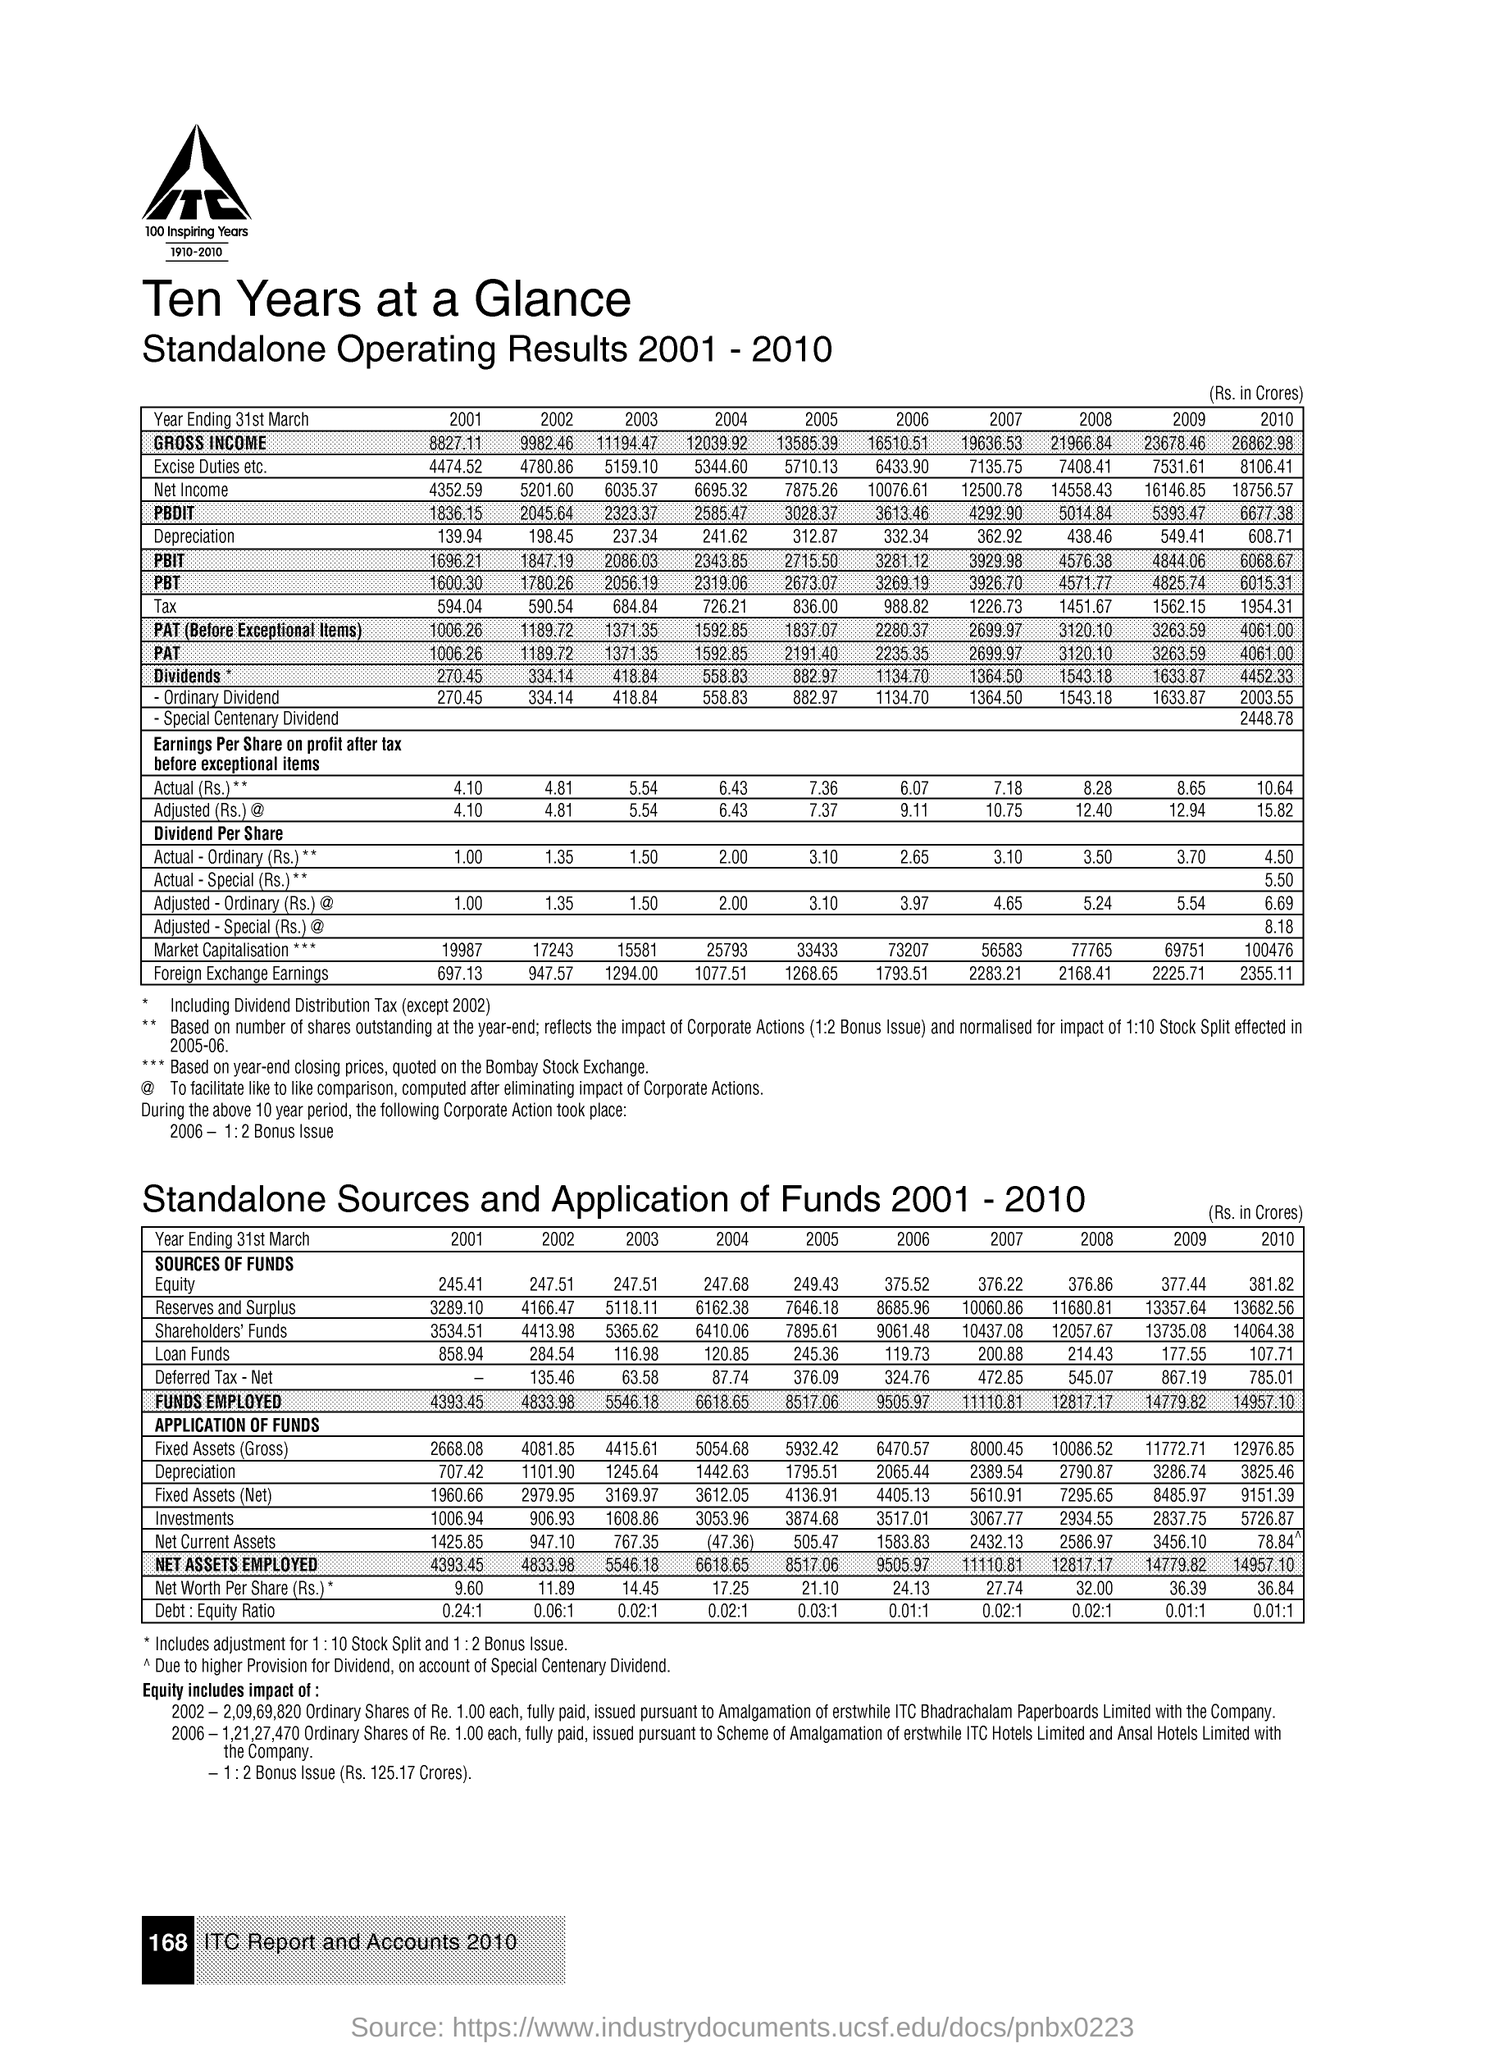Draw attention to some important aspects in this diagram. The second title in the document is 'Standalone Operating Results 2001-2010.' The first title in the document is 'Ten Years at a Glance....' 